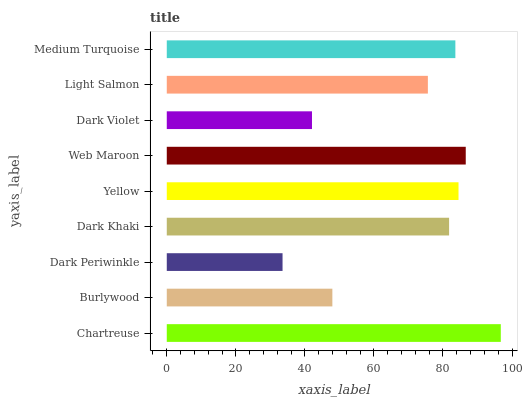Is Dark Periwinkle the minimum?
Answer yes or no. Yes. Is Chartreuse the maximum?
Answer yes or no. Yes. Is Burlywood the minimum?
Answer yes or no. No. Is Burlywood the maximum?
Answer yes or no. No. Is Chartreuse greater than Burlywood?
Answer yes or no. Yes. Is Burlywood less than Chartreuse?
Answer yes or no. Yes. Is Burlywood greater than Chartreuse?
Answer yes or no. No. Is Chartreuse less than Burlywood?
Answer yes or no. No. Is Dark Khaki the high median?
Answer yes or no. Yes. Is Dark Khaki the low median?
Answer yes or no. Yes. Is Medium Turquoise the high median?
Answer yes or no. No. Is Dark Periwinkle the low median?
Answer yes or no. No. 